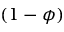<formula> <loc_0><loc_0><loc_500><loc_500>( 1 - \phi )</formula> 